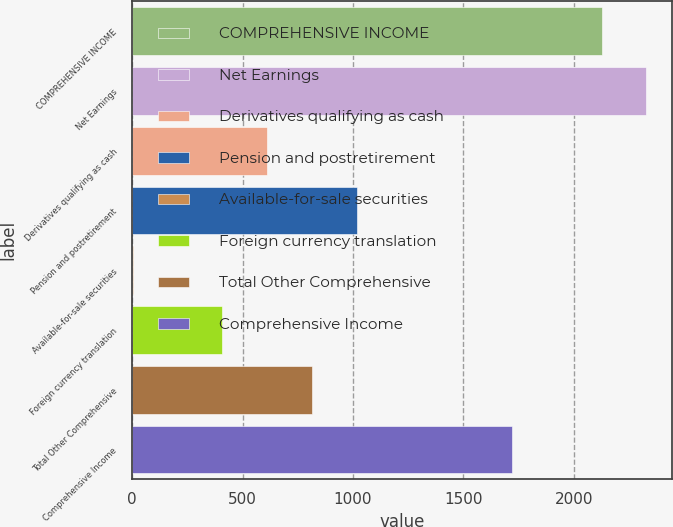Convert chart to OTSL. <chart><loc_0><loc_0><loc_500><loc_500><bar_chart><fcel>COMPREHENSIVE INCOME<fcel>Net Earnings<fcel>Derivatives qualifying as cash<fcel>Pension and postretirement<fcel>Available-for-sale securities<fcel>Foreign currency translation<fcel>Total Other Comprehensive<fcel>Comprehensive Income<nl><fcel>2125.2<fcel>2327.8<fcel>610.8<fcel>1016<fcel>3<fcel>408.2<fcel>813.4<fcel>1720<nl></chart> 